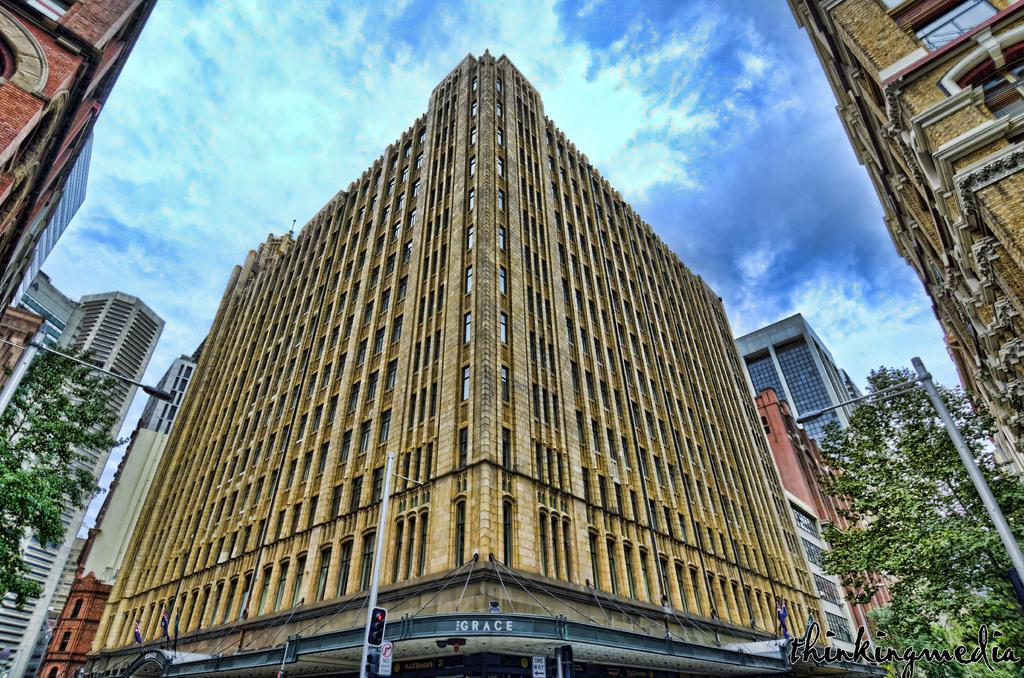What type of structures can be seen in the image? There are buildings in the image. What type of vegetation is present in the image? There are trees in the image. What are the tall, thin objects in the image? There are poles in the image. What is visible at the top of the image? The sky is visible in the image. Can you see a squirrel climbing up one of the trees in the image? There is no squirrel present in the image. What type of weather condition is depicted in the image, such as mist or fog? There is no indication of mist or fog in the image; the sky is visible. 